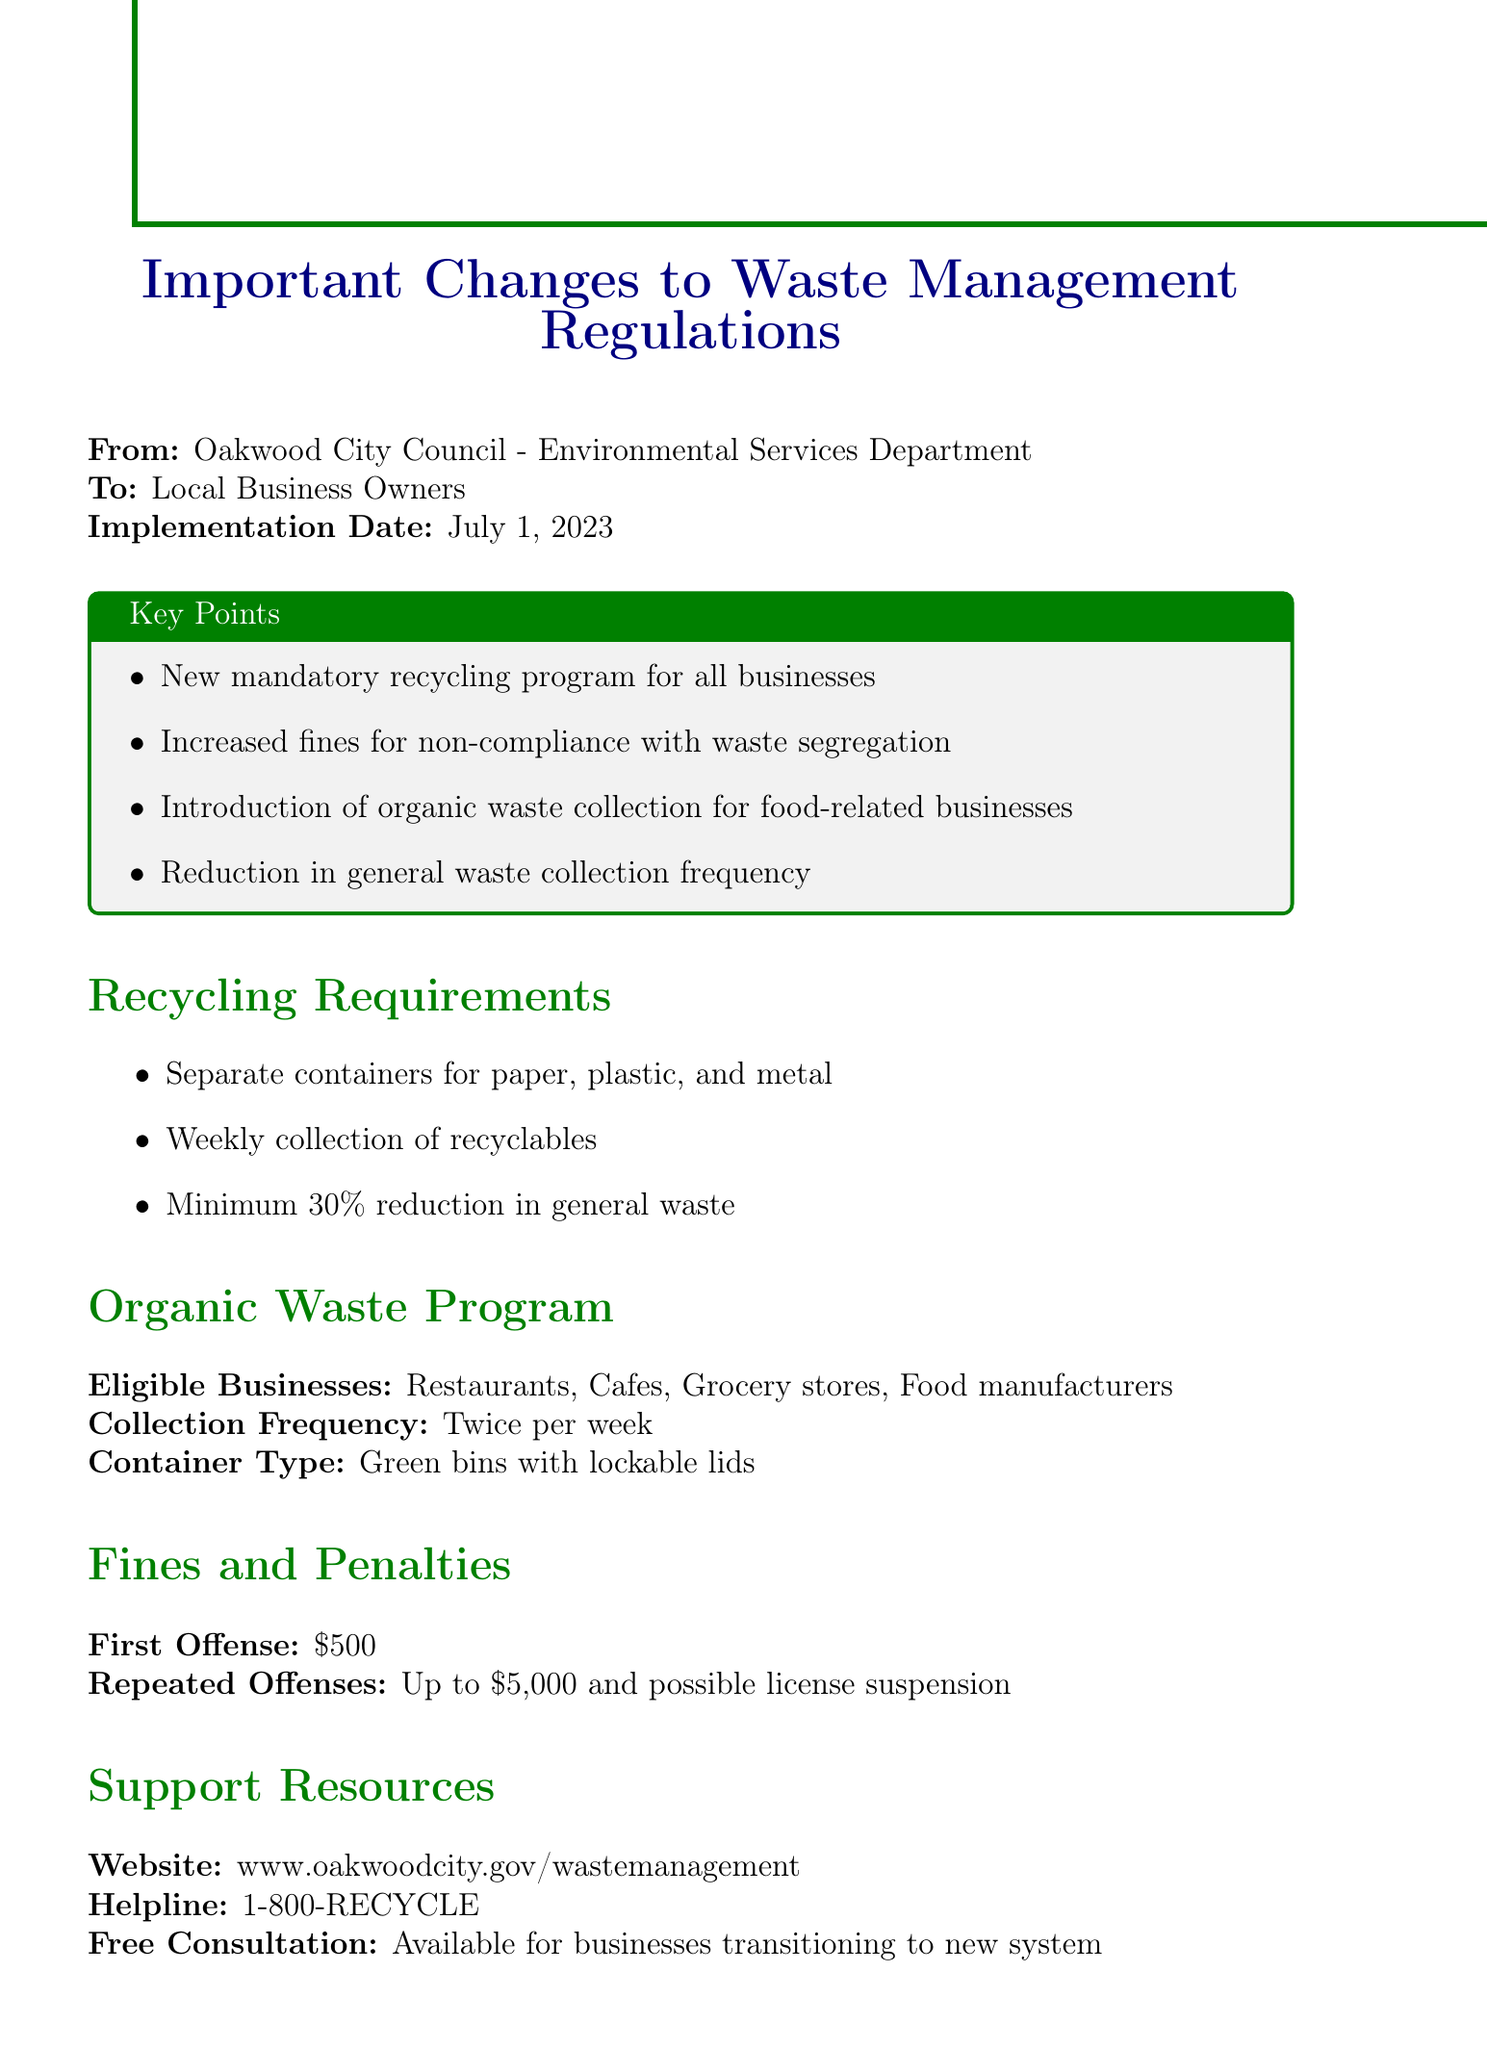What is the implementation date of the new regulations? The implementation date is explicitly stated in the document.
Answer: July 1, 2023 What is the fine for the first offense of non-compliance? The document specifies the fines and penalties for non-compliance.
Answer: $500 What type of containers are used for organic waste collection? The document details the requirements for the organic waste program.
Answer: Green bins with lockable lids How often are recyclables collected? The recycling requirements listed in the document include the collection frequency.
Answer: Weekly What is the expected reduction in landfill waste by 2025? The document mentions the anticipated environmental impact of the new regulations.
Answer: 40% What businesses are eligible for the organic waste program? The document lists the types of businesses that can participate in the organic waste collection.
Answer: Restaurants, Cafes, Grocery stores, Food manufacturers What is one potential benefit of the new regulations for businesses? The document outlines the advantages of compliance with the new waste management regulations.
Answer: Potential cost savings through reduced waste disposal fees What should businesses do if they need support during the transition? The document provides resources for businesses needing assistance.
Answer: Free Consultation available for businesses transitioning to new system 